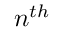<formula> <loc_0><loc_0><loc_500><loc_500>n ^ { t h }</formula> 